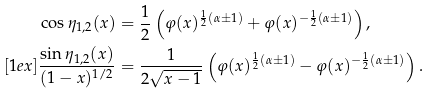<formula> <loc_0><loc_0><loc_500><loc_500>& \cos \eta _ { 1 , 2 } ( x ) = \frac { 1 } { 2 } \left ( \varphi ( x ) ^ { \frac { 1 } { 2 } ( \alpha \pm 1 ) } + \varphi ( x ) ^ { - \frac { 1 } { 2 } ( \alpha \pm 1 ) } \right ) , \\ [ 1 e x ] & \frac { \sin \eta _ { 1 , 2 } ( x ) } { ( 1 - x ) ^ { 1 / 2 } } = \frac { 1 } { 2 \sqrt { x - 1 } } \left ( \varphi ( x ) ^ { \frac { 1 } { 2 } ( \alpha \pm 1 ) } - \varphi ( x ) ^ { - \frac { 1 } { 2 } ( \alpha \pm 1 ) } \right ) .</formula> 